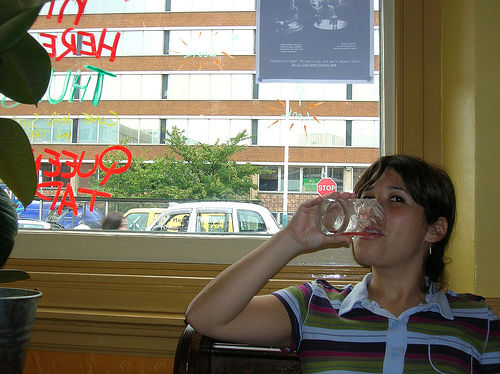<image>
Is there a girl to the left of the plant? No. The girl is not to the left of the plant. From this viewpoint, they have a different horizontal relationship. 